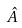Convert formula to latex. <formula><loc_0><loc_0><loc_500><loc_500>\hat { A }</formula> 